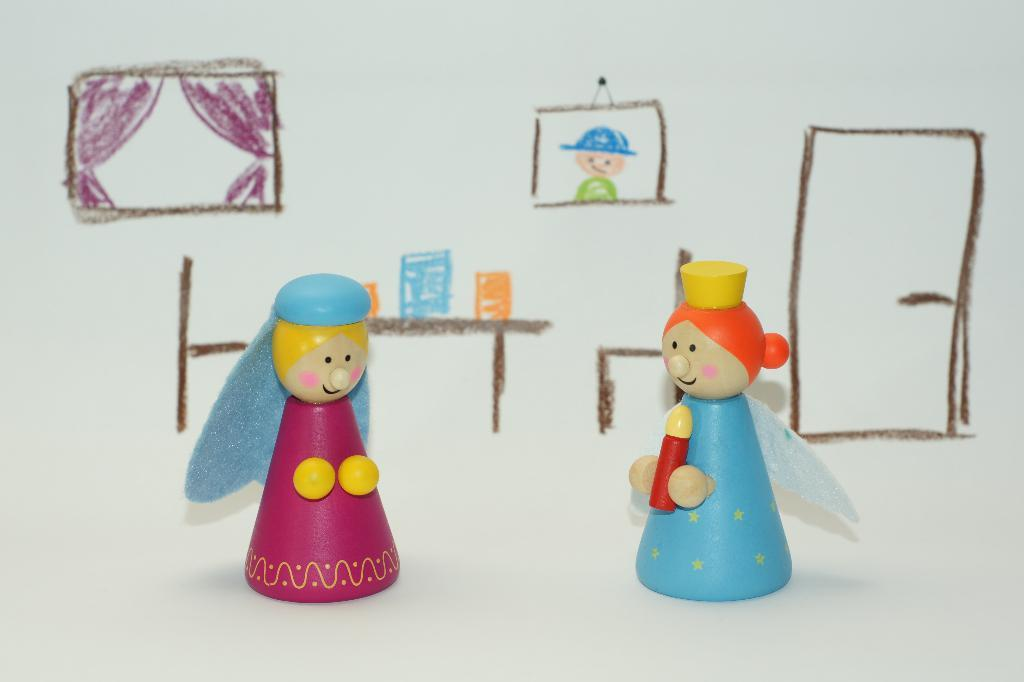What is depicted on the paper in the image? There is a drawing on a paper in the image. What tool was used to create the drawing? Crayons were used to create the drawing. How many dolls are present in the image? There are two dolls in the image. What type of insurance policy is being discussed by the dolls in the image? There is no indication in the image that the dolls are discussing any insurance policies. 